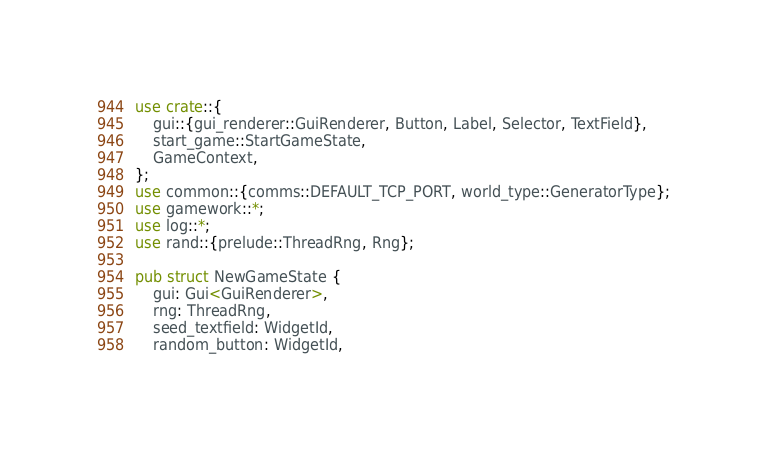Convert code to text. <code><loc_0><loc_0><loc_500><loc_500><_Rust_>use crate::{
    gui::{gui_renderer::GuiRenderer, Button, Label, Selector, TextField},
    start_game::StartGameState,
    GameContext,
};
use common::{comms::DEFAULT_TCP_PORT, world_type::GeneratorType};
use gamework::*;
use log::*;
use rand::{prelude::ThreadRng, Rng};

pub struct NewGameState {
    gui: Gui<GuiRenderer>,
    rng: ThreadRng,
    seed_textfield: WidgetId,
    random_button: WidgetId,</code> 